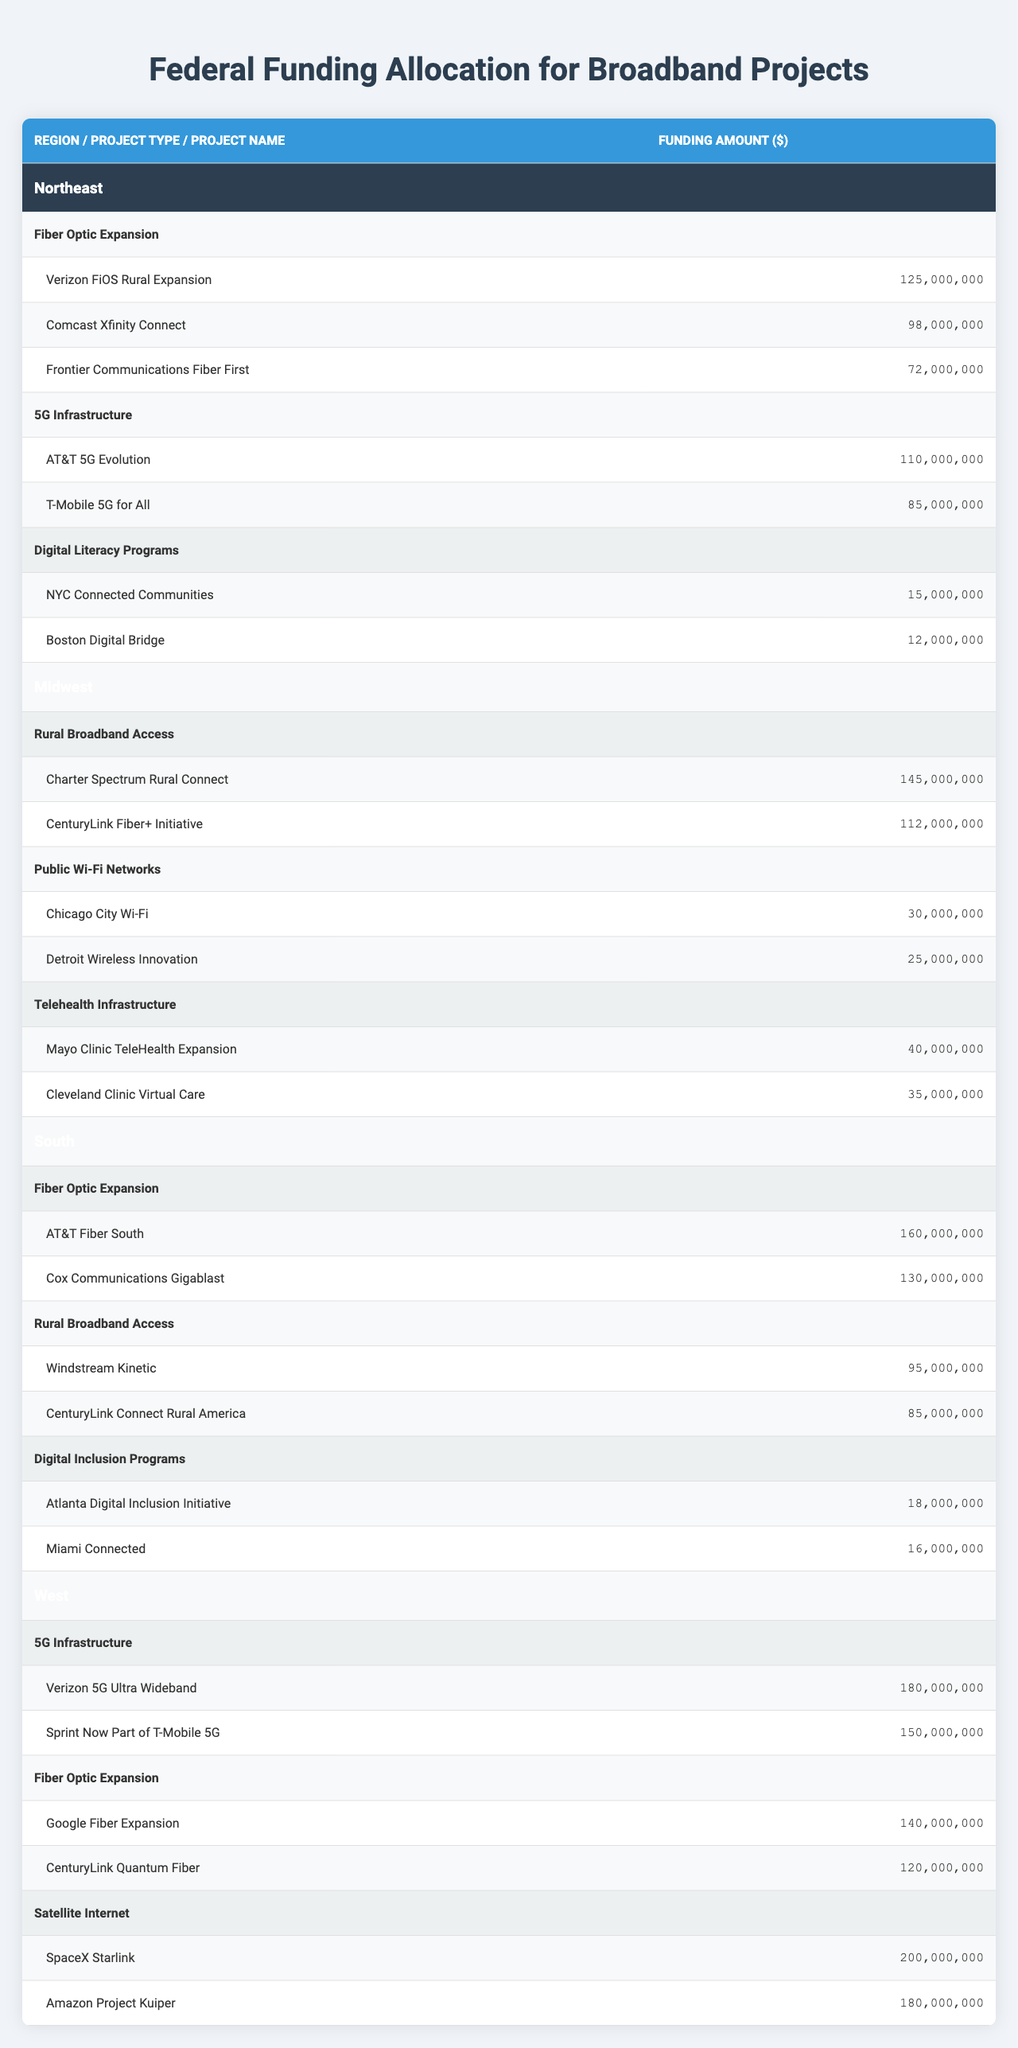What is the total funding for Fiber Optic Expansion projects in the Northeast? For Fiber Optic Expansion in the Northeast, the projects are Verizon FiOS Rural Expansion ($125,000,000), Comcast Xfinity Connect ($98,000,000), and Frontier Communications Fiber First ($72,000,000). Summing these values gives $125,000,000 + $98,000,000 + $72,000,000 = $295,000,000.
Answer: $295,000,000 Which region has the highest funding for Satellite Internet? The only region with Satellite Internet projects is the West, which includes SpaceX Starlink ($200,000,000) and Amazon Project Kuiper ($180,000,000). Since no other region has Satellite Internet projects, the West has the highest funding in this category.
Answer: West What is the average funding amount for 5G Infrastructure projects across all regions? The 5G Infrastructure projects include: Northeast ($110,000,000 + $85,000,000), Midwest (none), South (none), and West ($180,000,000 + $150,000,000). The total funding for 5G Infrastructure projects is $110,000,000 + $85,000,000 + $180,000,000 + $150,000,000 = $525,000,000. There are 4 projects, so the average is $525,000,000 / 4 = $131,250,000.
Answer: $131,250,000 Is there any funding allocated for Digital Literacy Programs in the Midwest? The Midwest section does not list any Digital Literacy Programs. Instead, it includes Rural Broadband Access, Public Wi-Fi Networks, and Telehealth Infrastructure. Hence, there is no funding allocated for Digital Literacy Programs in this region.
Answer: No What is the total funding for all Digital Inclusion Programs in the South? The Digital Inclusion Programs in the South include Atlanta Digital Inclusion Initiative ($18,000,000) and Miami Connected ($16,000,000). Summing these values gives $18,000,000 + $16,000,000 = $34,000,000.
Answer: $34,000,000 Which project has the highest funding in the entire table? Upon reviewing all project funding amounts, SpaceX Starlink has the highest funding at $200,000,000. This can be verified by comparing each project amount across all regions and project types.
Answer: SpaceX Starlink What is the difference in funding between the highest project in the Northeast and the highest project in the South? The highest project in the Northeast is Verizon FiOS Rural Expansion at $125,000,000, and the highest project in the South is AT&T Fiber South at $160,000,000. The difference is $160,000,000 - $125,000,000 = $35,000,000.
Answer: $35,000,000 How much funding is allocated for Telehealth Infrastructure in the Midwest compared to 5G Infrastructure in the Northeast? Telehealth Infrastructure in the Midwest includes Mayo Clinic TeleHealth Expansion ($40,000,000) and Cleveland Clinic Virtual Care ($35,000,000), totaling $75,000,000. The 5G Infrastructure in the Northeast has a total of $195,000,000 ($110,000,000 + $85,000,000). Therefore, the Northeast has $195,000,000 - $75,000,000 = $120,000,000 more funding allocated for 5G Infrastructure compared to Telehealth Infrastructure in the Midwest.
Answer: $120,000,000 What percentage of total funding in the Midwest is allocated to Rural Broadband Access? In the Midwest, the total funding for Rural Broadband Access is $145,000,000 + $112,000,000 = $257,000,000. The total funding for all projects in the Midwest is $257,000,000 + $30,000,000 + $40,000,000 + $35,000,000 = $362,000,000. The percentage allocated to Rural Broadband Access is ($257,000,000 / $362,000,000) * 100 = 71.1%.
Answer: 71.1% 